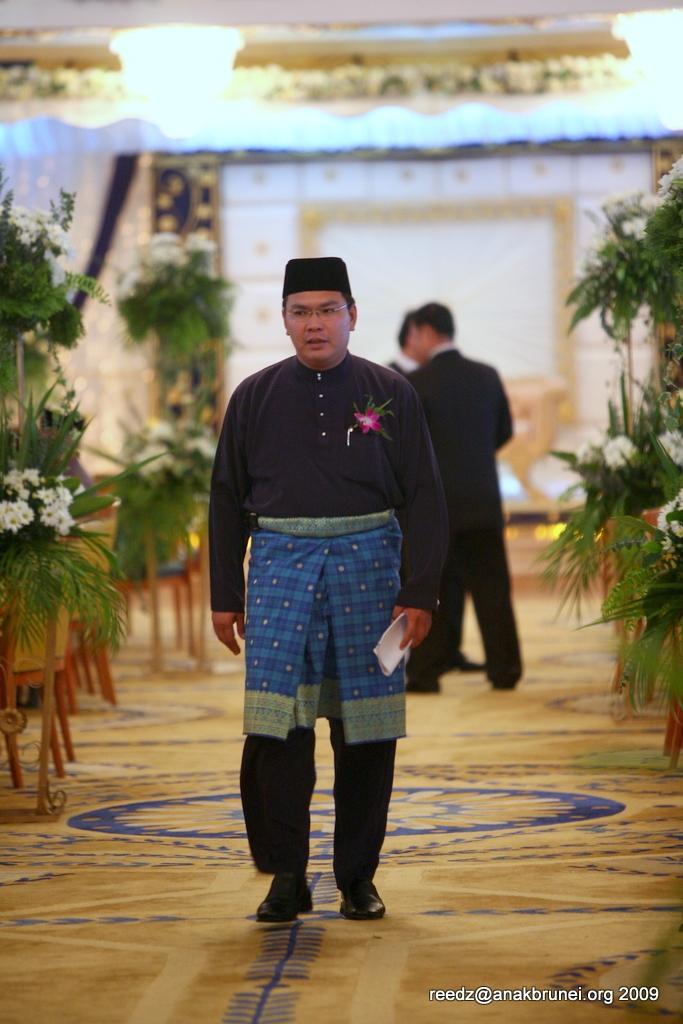In one or two sentences, can you explain what this image depicts? In the center of this picture we can see the group of persons. In the foreground there is a person wearing black color dress, holding an object and walking on the ground. In the background we can see the curtains, light and the flowers. At the bottom there is a text and numbers on the image. 